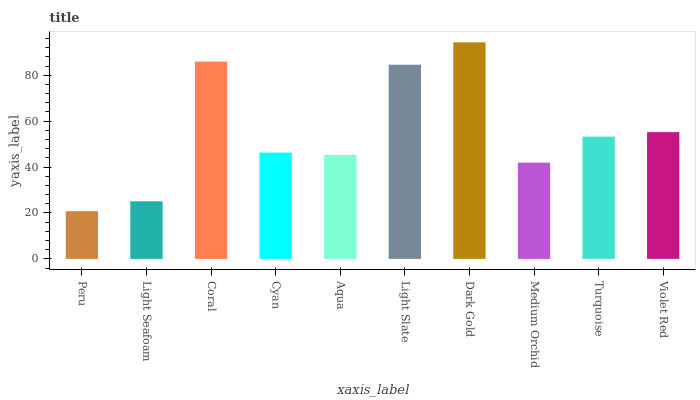Is Peru the minimum?
Answer yes or no. Yes. Is Dark Gold the maximum?
Answer yes or no. Yes. Is Light Seafoam the minimum?
Answer yes or no. No. Is Light Seafoam the maximum?
Answer yes or no. No. Is Light Seafoam greater than Peru?
Answer yes or no. Yes. Is Peru less than Light Seafoam?
Answer yes or no. Yes. Is Peru greater than Light Seafoam?
Answer yes or no. No. Is Light Seafoam less than Peru?
Answer yes or no. No. Is Turquoise the high median?
Answer yes or no. Yes. Is Cyan the low median?
Answer yes or no. Yes. Is Dark Gold the high median?
Answer yes or no. No. Is Turquoise the low median?
Answer yes or no. No. 